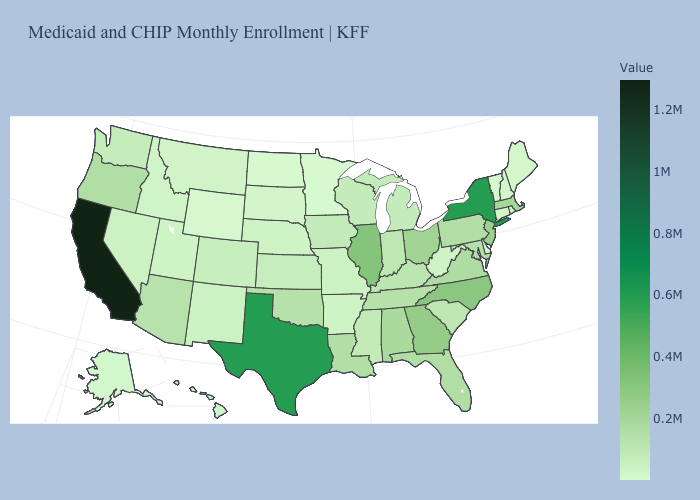Among the states that border South Dakota , does Minnesota have the lowest value?
Be succinct. Yes. Which states have the lowest value in the USA?
Quick response, please. Minnesota. Does New Hampshire have the highest value in the Northeast?
Answer briefly. No. Is the legend a continuous bar?
Be succinct. Yes. Among the states that border California , does Arizona have the lowest value?
Answer briefly. No. 